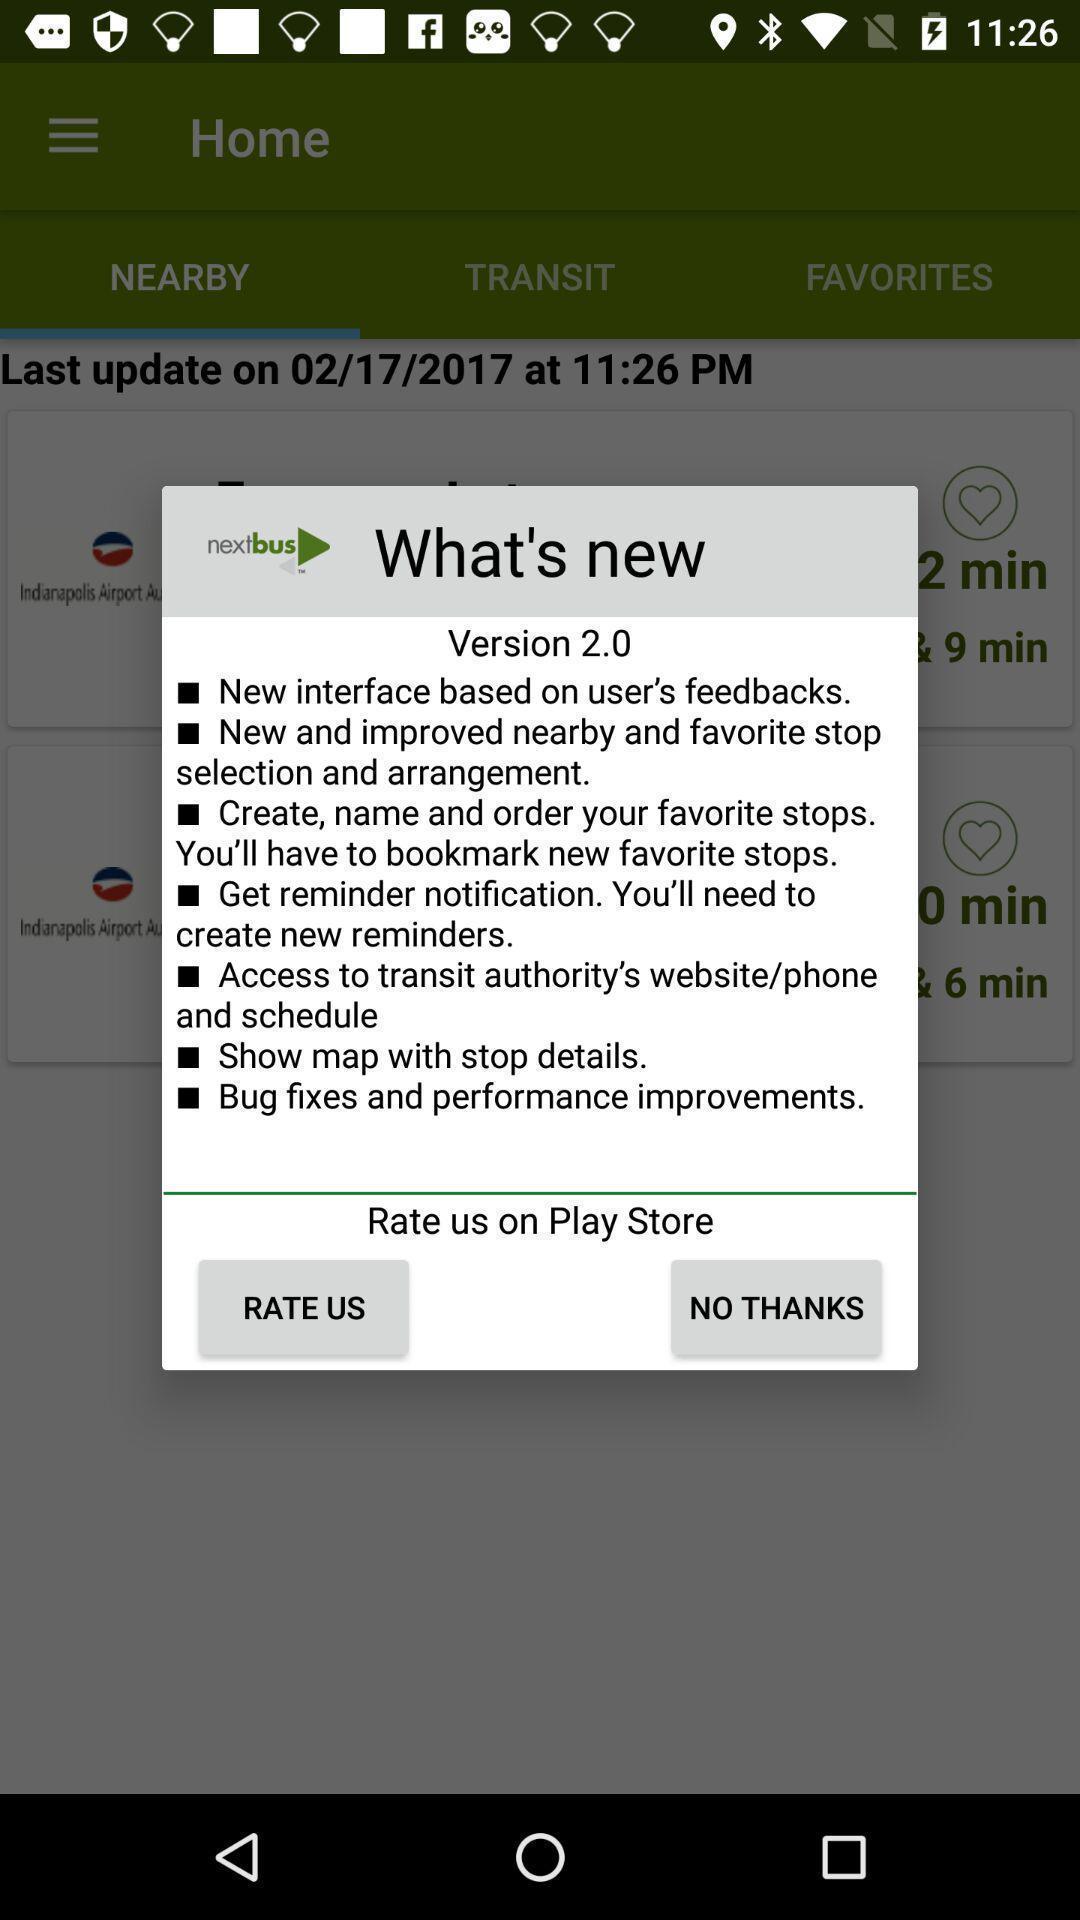Summarize the information in this screenshot. Pop-up showing the updated version details about the app. 